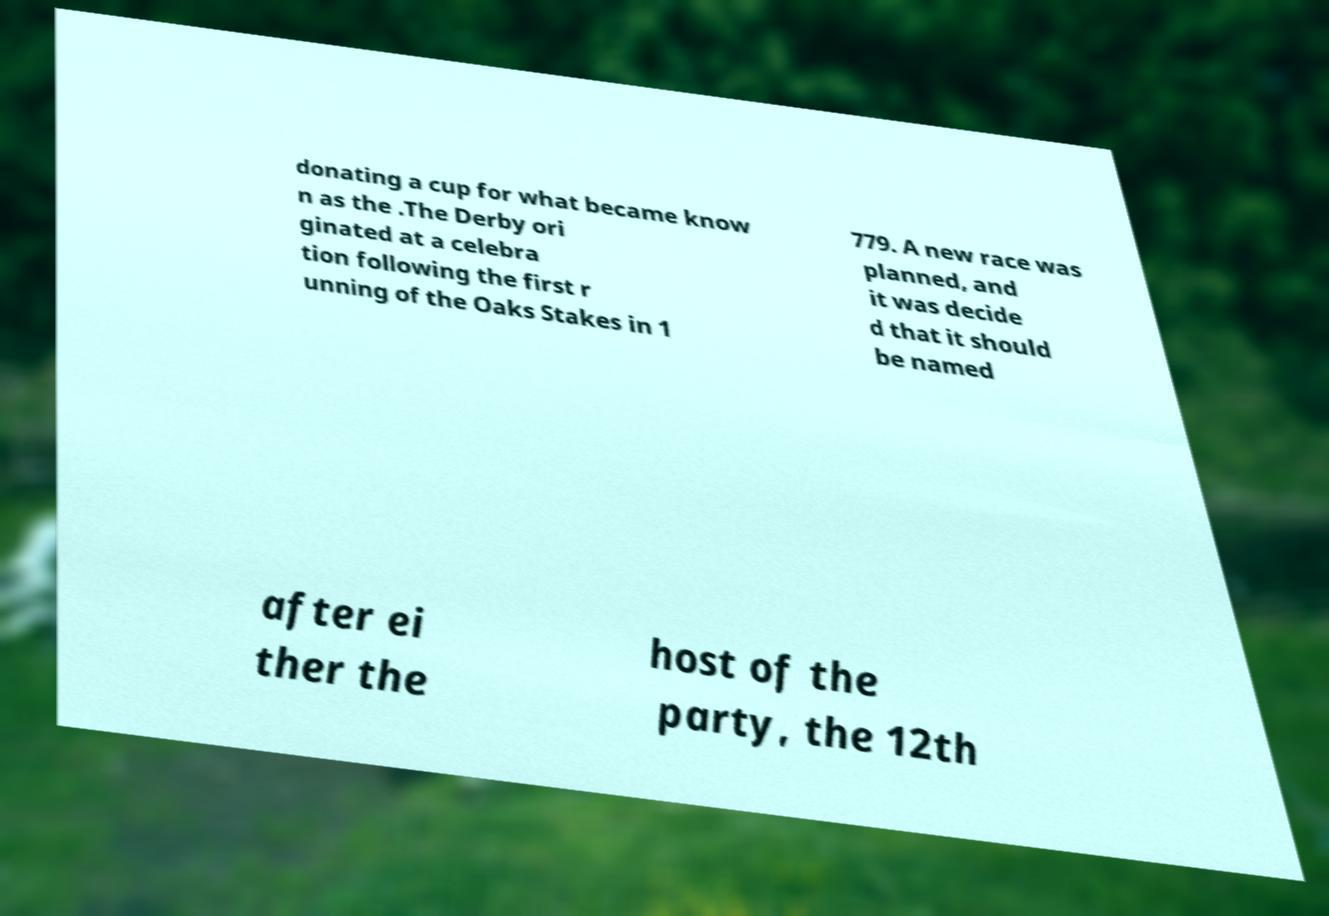Can you read and provide the text displayed in the image?This photo seems to have some interesting text. Can you extract and type it out for me? donating a cup for what became know n as the .The Derby ori ginated at a celebra tion following the first r unning of the Oaks Stakes in 1 779. A new race was planned, and it was decide d that it should be named after ei ther the host of the party, the 12th 